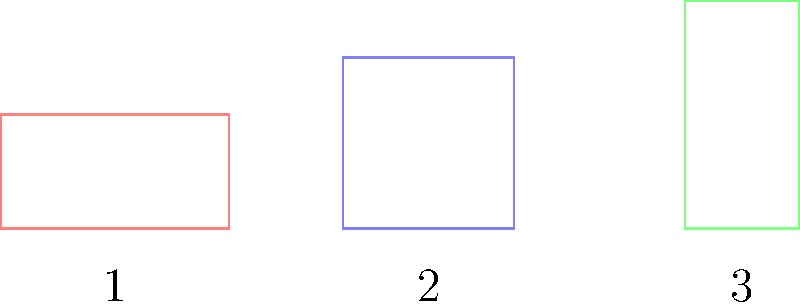Match the 3D building silhouettes (A, B, C) to their corresponding 2D floor plans (1, 2, 3). Which combination is correct? To match the 3D building silhouettes to their 2D floor plans, we need to analyze the dimensions and proportions of each building:

1. Building A:
   - It has a rectangular base with length approximately twice its width.
   - The height is greater than both the length and width.

2. Building B:
   - It has a rectangular base with width greater than its length.
   - The height is similar to the width but greater than the length.

3. Building C:
   - It has a square base (length and width are equal).
   - The height is greater than the base dimensions.

Now, let's examine the 2D floor plans:

1. Floor plan 1:
   - Rectangular shape with length twice the width.

2. Floor plan 2:
   - Square shape with equal length and width.

3. Floor plan 3:
   - Rectangular shape with width greater than length.

Matching the characteristics:
- Building A matches floor plan 1 (rectangular, length twice the width)
- Building B matches floor plan 3 (rectangular, width greater than length)
- Building C matches floor plan 2 (square base)

Therefore, the correct combination is: A-1, B-3, C-2.
Answer: A-1, B-3, C-2 